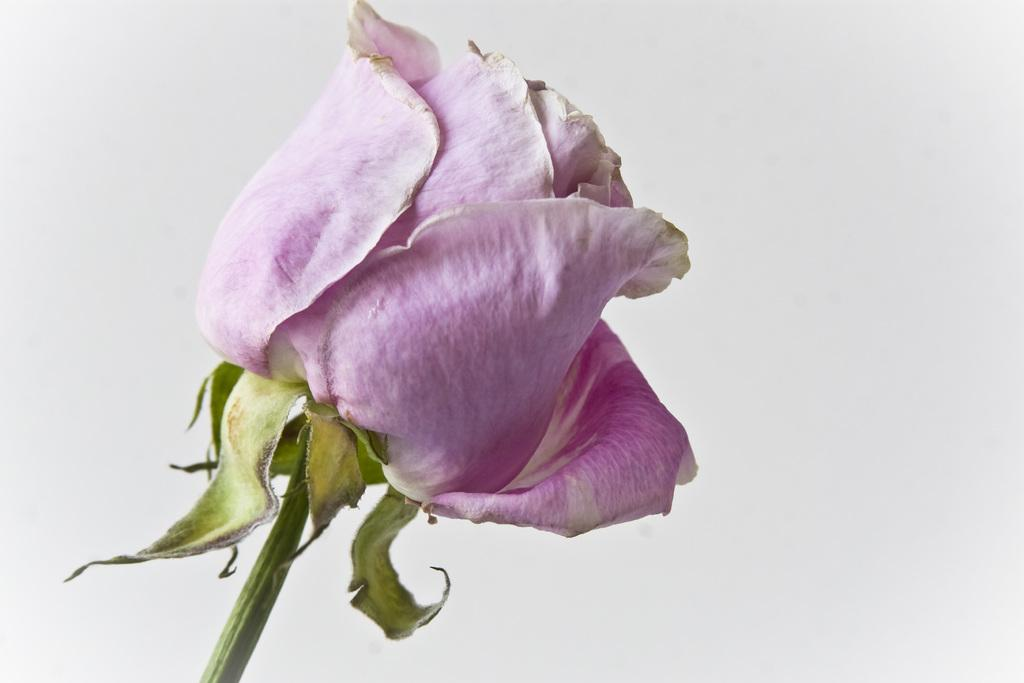What type of flower is in the image? There is a rose in the image. What is the color of the rose? The rose has a pink color. What part of the rose is visible in the image? The stem is visible in the image. What is the color of the stem? The stem has a green color. What color is the background of the image? The background of the image has a white color. How does the popcorn affect the balance of the rose in the image? There is no popcorn present in the image, so it cannot affect the balance of the rose. 